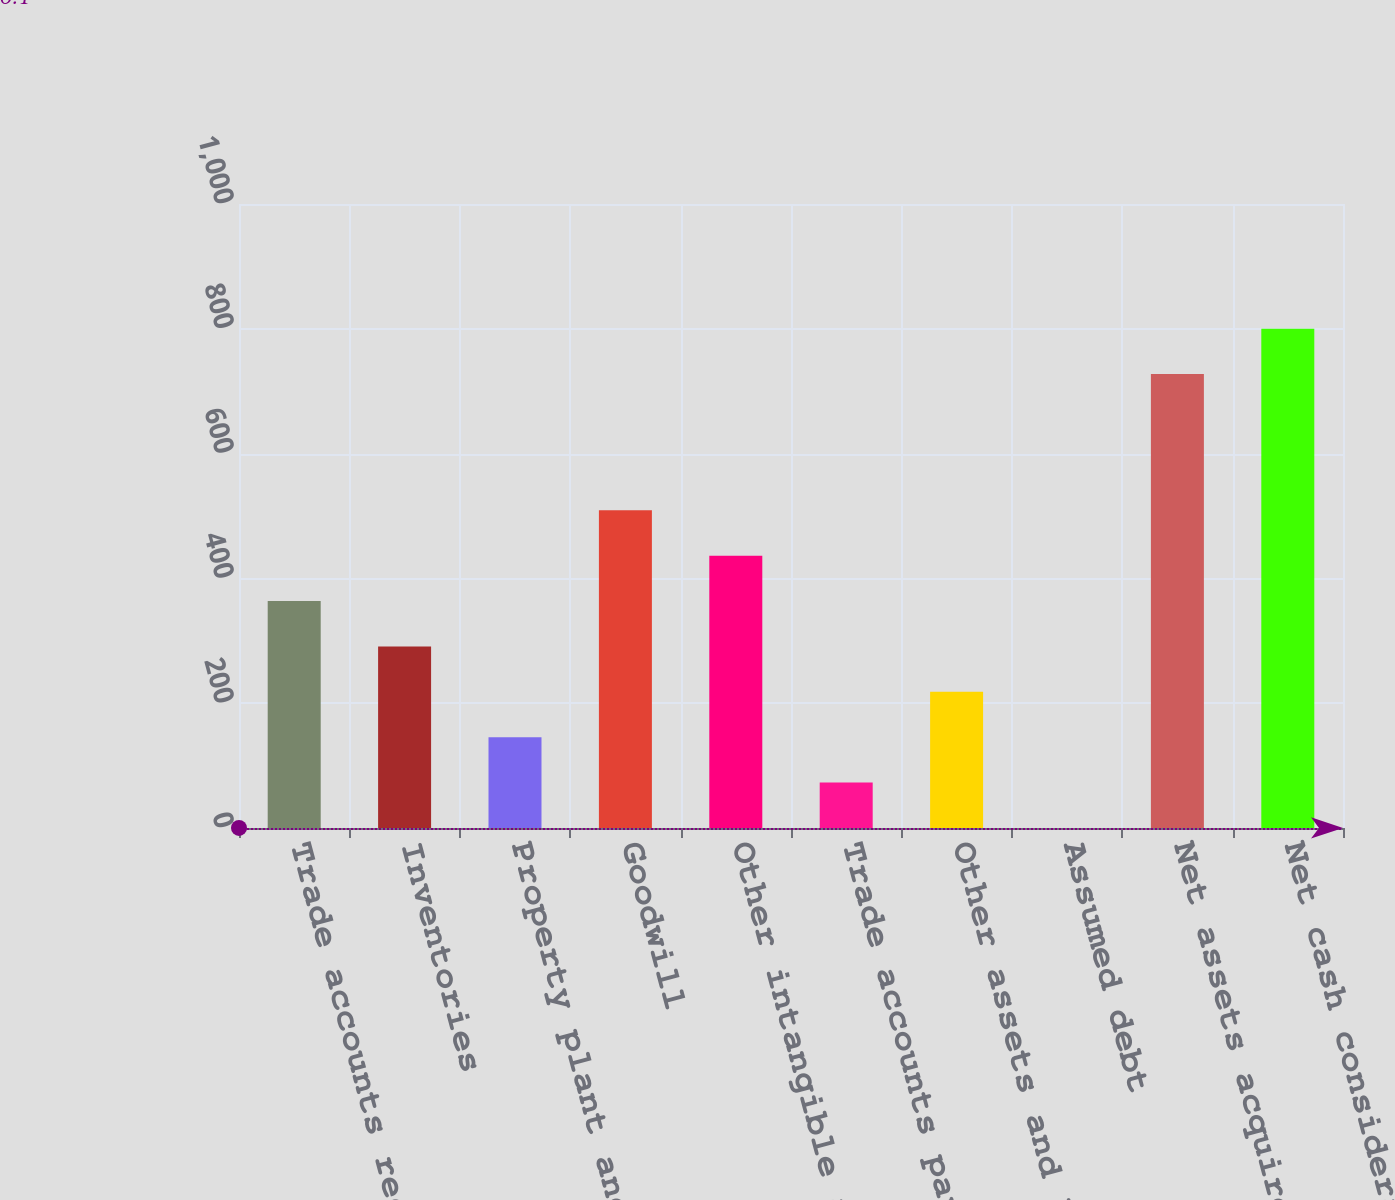Convert chart. <chart><loc_0><loc_0><loc_500><loc_500><bar_chart><fcel>Trade accounts receivable<fcel>Inventories<fcel>Property plant and equipment<fcel>Goodwill<fcel>Other intangible assets<fcel>Trade accounts payable<fcel>Other assets and liabilities<fcel>Assumed debt<fcel>Net assets acquired<fcel>Net cash consideration<nl><fcel>363.75<fcel>291.02<fcel>145.56<fcel>509.21<fcel>436.48<fcel>72.83<fcel>218.29<fcel>0.1<fcel>727.4<fcel>800.13<nl></chart> 